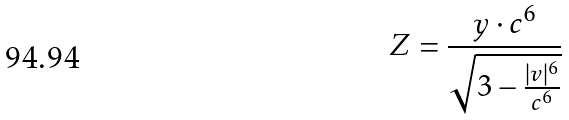<formula> <loc_0><loc_0><loc_500><loc_500>Z = \frac { y \cdot c ^ { 6 } } { \sqrt { 3 - \frac { | v | ^ { 6 } } { c ^ { 6 } } } }</formula> 